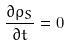<formula> <loc_0><loc_0><loc_500><loc_500>\frac { \partial \rho _ { S } } { \partial t } = 0</formula> 